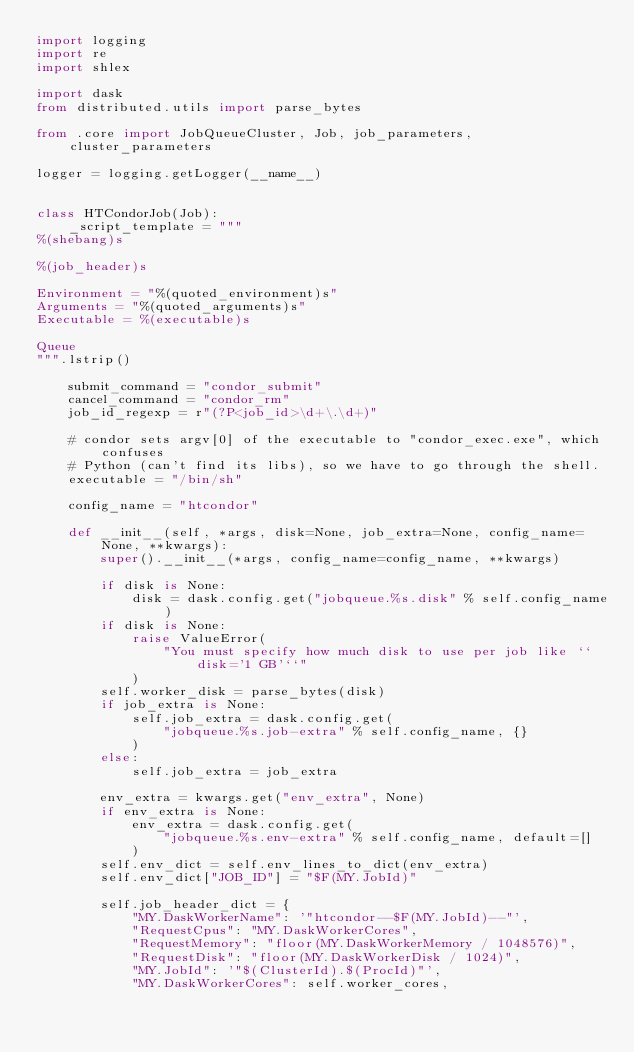Convert code to text. <code><loc_0><loc_0><loc_500><loc_500><_Python_>import logging
import re
import shlex

import dask
from distributed.utils import parse_bytes

from .core import JobQueueCluster, Job, job_parameters, cluster_parameters

logger = logging.getLogger(__name__)


class HTCondorJob(Job):
    _script_template = """
%(shebang)s

%(job_header)s

Environment = "%(quoted_environment)s"
Arguments = "%(quoted_arguments)s"
Executable = %(executable)s

Queue
""".lstrip()

    submit_command = "condor_submit"
    cancel_command = "condor_rm"
    job_id_regexp = r"(?P<job_id>\d+\.\d+)"

    # condor sets argv[0] of the executable to "condor_exec.exe", which confuses
    # Python (can't find its libs), so we have to go through the shell.
    executable = "/bin/sh"

    config_name = "htcondor"

    def __init__(self, *args, disk=None, job_extra=None, config_name=None, **kwargs):
        super().__init__(*args, config_name=config_name, **kwargs)

        if disk is None:
            disk = dask.config.get("jobqueue.%s.disk" % self.config_name)
        if disk is None:
            raise ValueError(
                "You must specify how much disk to use per job like ``disk='1 GB'``"
            )
        self.worker_disk = parse_bytes(disk)
        if job_extra is None:
            self.job_extra = dask.config.get(
                "jobqueue.%s.job-extra" % self.config_name, {}
            )
        else:
            self.job_extra = job_extra

        env_extra = kwargs.get("env_extra", None)
        if env_extra is None:
            env_extra = dask.config.get(
                "jobqueue.%s.env-extra" % self.config_name, default=[]
            )
        self.env_dict = self.env_lines_to_dict(env_extra)
        self.env_dict["JOB_ID"] = "$F(MY.JobId)"

        self.job_header_dict = {
            "MY.DaskWorkerName": '"htcondor--$F(MY.JobId)--"',
            "RequestCpus": "MY.DaskWorkerCores",
            "RequestMemory": "floor(MY.DaskWorkerMemory / 1048576)",
            "RequestDisk": "floor(MY.DaskWorkerDisk / 1024)",
            "MY.JobId": '"$(ClusterId).$(ProcId)"',
            "MY.DaskWorkerCores": self.worker_cores,</code> 